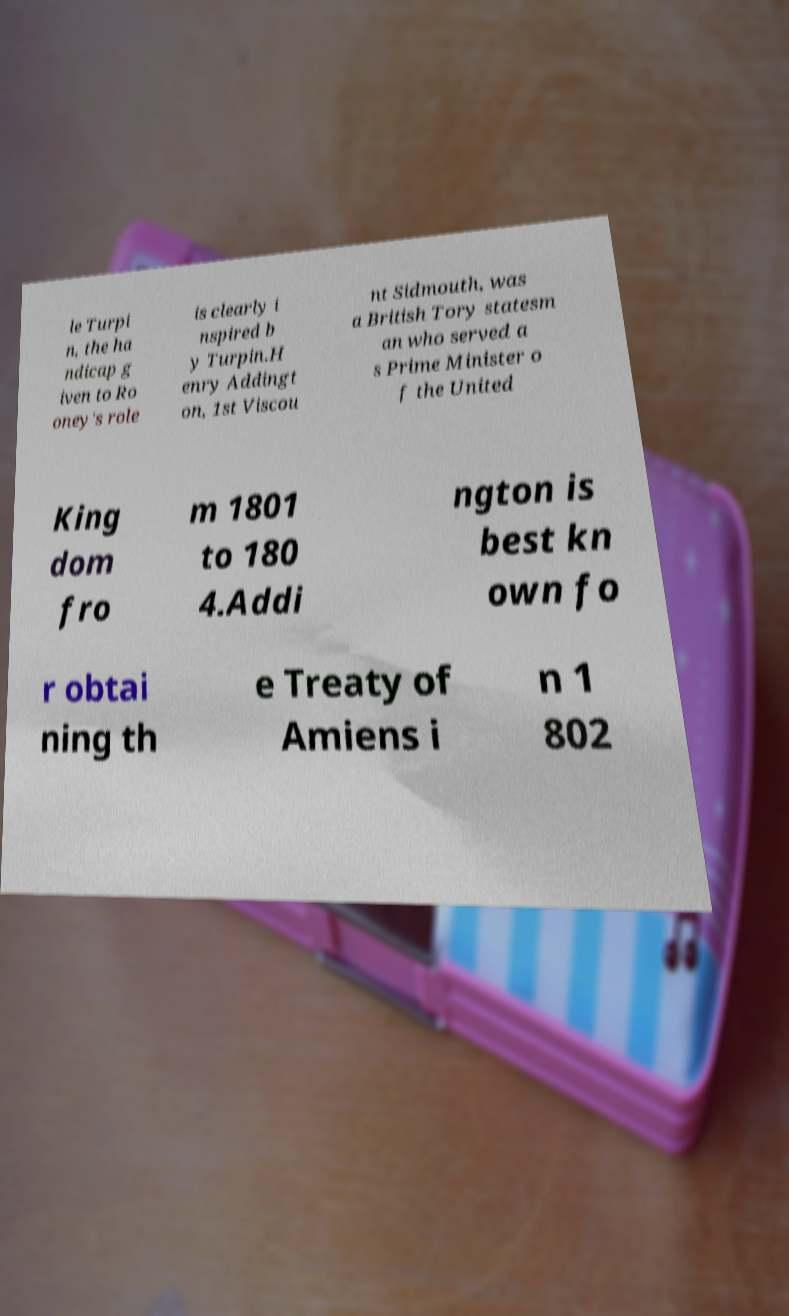There's text embedded in this image that I need extracted. Can you transcribe it verbatim? le Turpi n, the ha ndicap g iven to Ro oney's role is clearly i nspired b y Turpin.H enry Addingt on, 1st Viscou nt Sidmouth, was a British Tory statesm an who served a s Prime Minister o f the United King dom fro m 1801 to 180 4.Addi ngton is best kn own fo r obtai ning th e Treaty of Amiens i n 1 802 